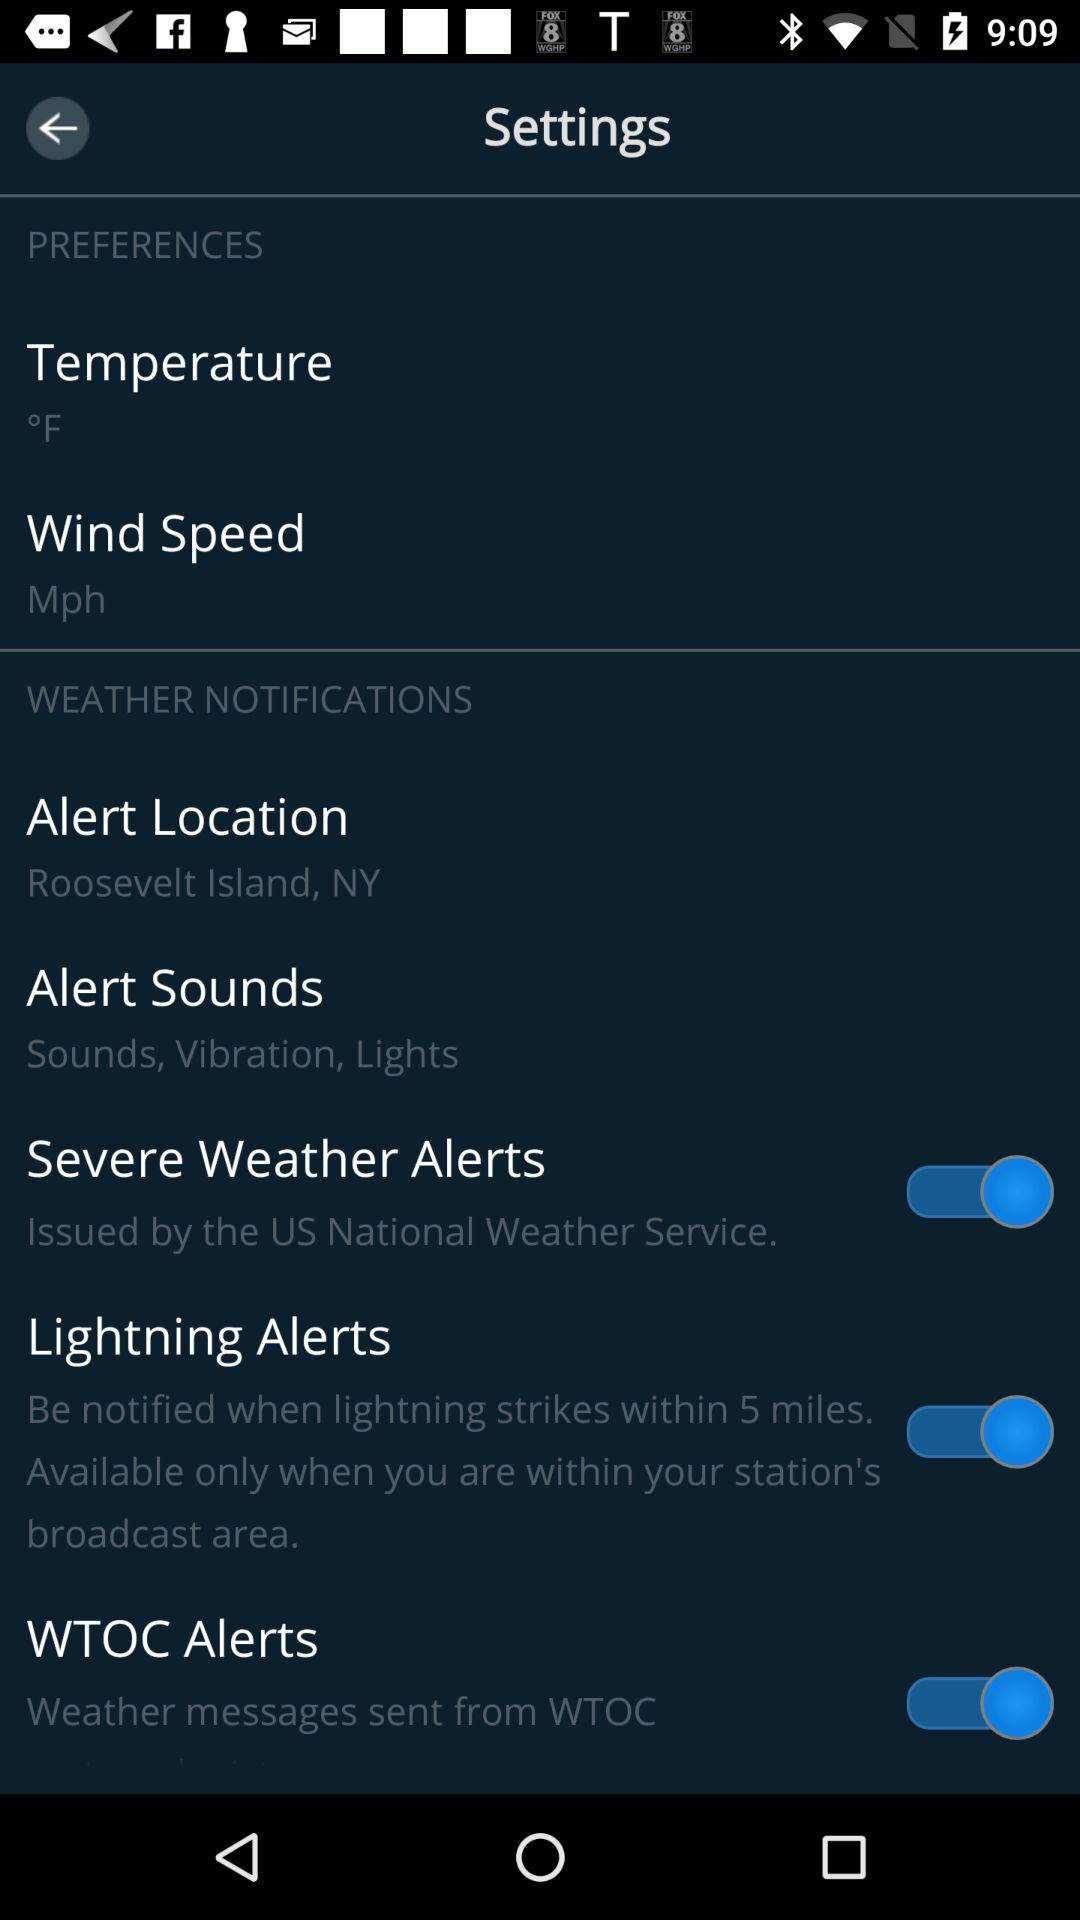What is the setting for "Severe Weather Alerts"? The setting is "on". 